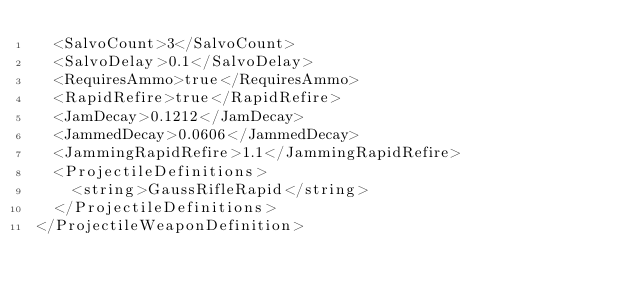<code> <loc_0><loc_0><loc_500><loc_500><_XML_>	<SalvoCount>3</SalvoCount>
	<SalvoDelay>0.1</SalvoDelay>
	<RequiresAmmo>true</RequiresAmmo>
	<RapidRefire>true</RapidRefire>
	<JamDecay>0.1212</JamDecay>
	<JammedDecay>0.0606</JammedDecay>
	<JammingRapidRefire>1.1</JammingRapidRefire>
	<ProjectileDefinitions>
		<string>GaussRifleRapid</string>
	</ProjectileDefinitions>
</ProjectileWeaponDefinition></code> 